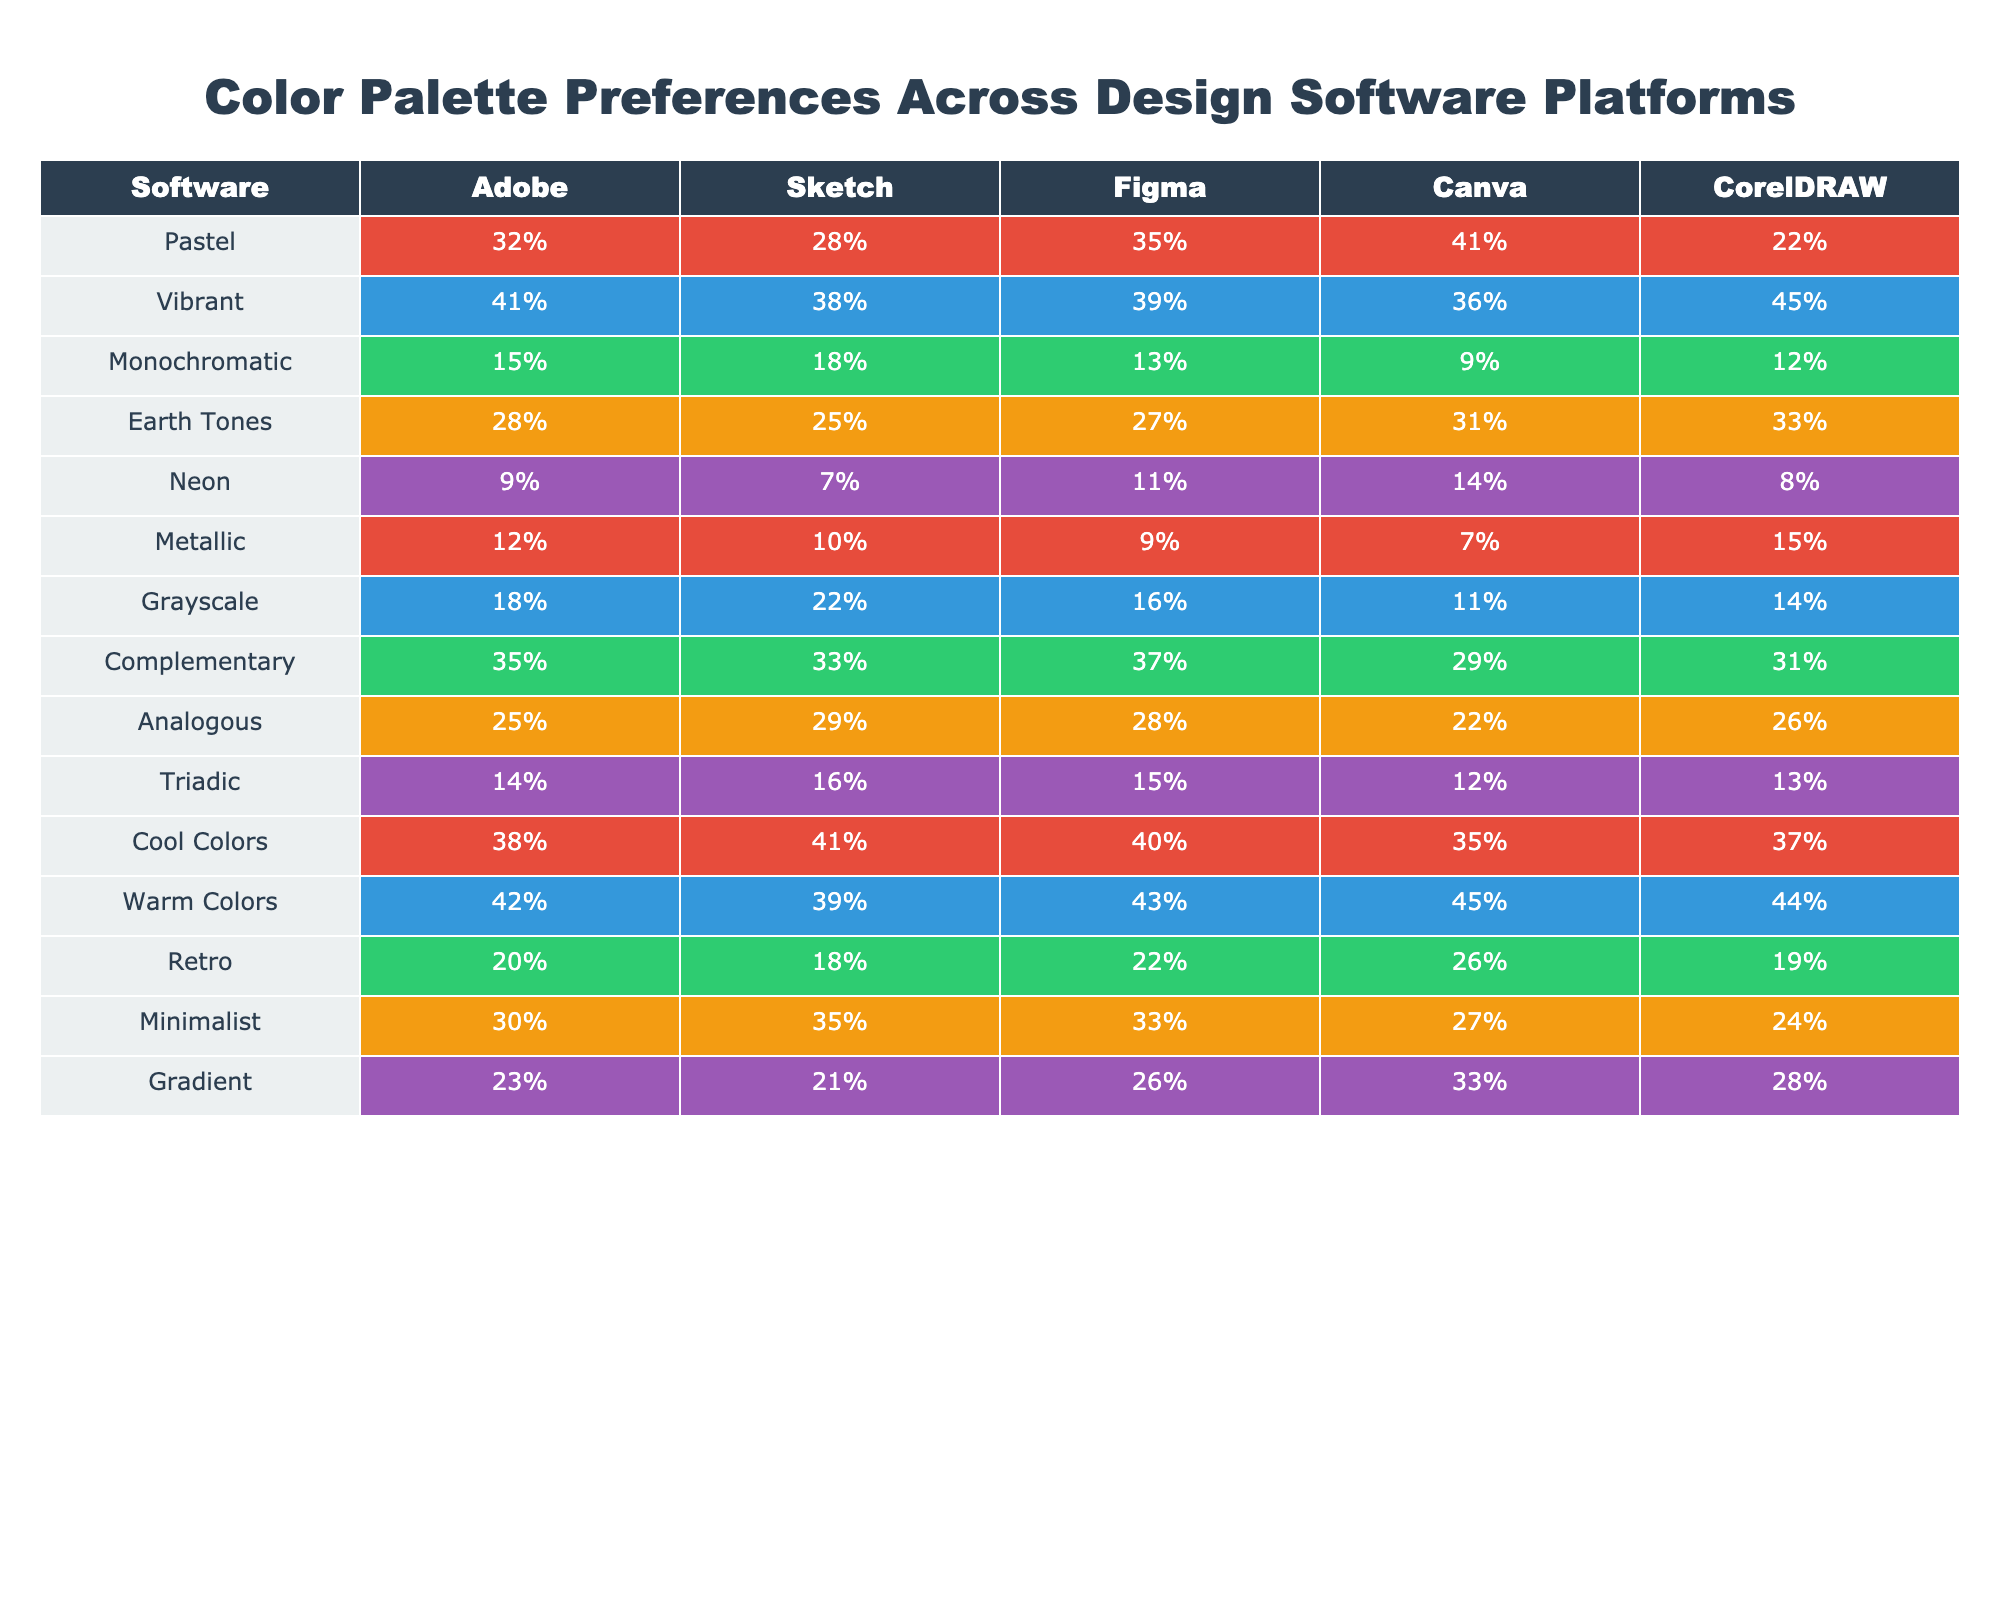What percentage of users prefer Warm Colors in Adobe? The table shows that 42% of users prefer Warm Colors in Adobe according to the corresponding row for Adobe.
Answer: 42% Which design software has the highest percentage preference for Neon colors? Figma has the highest preference for Neon colors at 11%, compared to the other software platforms listed in the table.
Answer: Figma What is the preference difference for Grayscale between Sketch and Canva? Sketch has a Grayscale preference of 22% while Canva has 11%. The difference is 22% - 11% = 11%.
Answer: 11% Which color palette preference is the most popular across all design platforms? The most popular color palette preference is Vibrant, with the highest percentages in Adobe (41%), Sketch (38%), and others. The average could be computed to confirm it's the highest overall.
Answer: Vibrant True or False: Figma has a higher preference for Pastel colors than CorelDRAW. Figma has a preference of 35% for Pastel colors while CorelDRAW has a preference of 22%. Thus, Figma has a higher preference, making the statement true.
Answer: True What are the total percentages of Earth Tones preferences across all platforms? To find the total, we sum the percentages of Earth Tones for each software: 28% (Adobe) + 25% (Sketch) + 27% (Figma) + 31% (Canva) + 33% (CorelDRAW) = 144%.
Answer: 144% Which software has the lowest preference for Minimalist colors? CorelDRAW has the lowest preference for Minimalist colors at 24%, which is the lowest value in that row across all software platforms.
Answer: CorelDRAW How does the preference for Cool Colors in Canva compare to the average preference of Cool Colors across all platforms? The preference for Cool Colors in Canva is 35%. The average preference across all platforms can be computed: (38% + 41% + 40% + 35% + 37%)/5 = 38.2%. Since 35% is lower than 38.2%, it is less than the average.
Answer: Lower than average Which two software platforms show the highest preferences for Complementary colors? Adobe shows 35% and Figma shows 37%. Figma has the highest at 37%, followed by Adobe at 35%.
Answer: Figma and Adobe What is the average preference for Retro colors across all platforms? The average for Retro colors is computed as: (20% + 18% + 22% + 26% + 19%)/5 = 21%.
Answer: 21% 